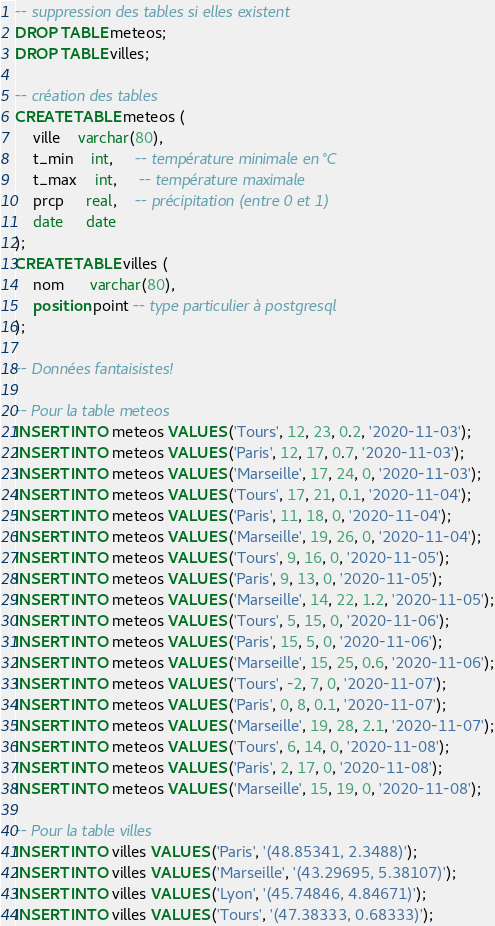<code> <loc_0><loc_0><loc_500><loc_500><_SQL_>-- suppression des tables si elles existent
DROP TABLE meteos;
DROP TABLE villes;

-- création des tables
CREATE TABLE meteos (
    ville    varchar(80),
    t_min    int,     -- température minimale en °C
    t_max    int,     -- température maximale
    prcp     real,    -- précipitation (entre 0 et 1)
    date     date
);
CREATE TABLE villes (
    nom      varchar(80),
    position point -- type particulier à postgresql
);

-- Données fantaisistes!

-- Pour la table meteos
INSERT INTO meteos VALUES ('Tours', 12, 23, 0.2, '2020-11-03');
INSERT INTO meteos VALUES ('Paris', 12, 17, 0.7, '2020-11-03');
INSERT INTO meteos VALUES ('Marseille', 17, 24, 0, '2020-11-03');
INSERT INTO meteos VALUES ('Tours', 17, 21, 0.1, '2020-11-04');
INSERT INTO meteos VALUES ('Paris', 11, 18, 0, '2020-11-04');
INSERT INTO meteos VALUES ('Marseille', 19, 26, 0, '2020-11-04');
INSERT INTO meteos VALUES ('Tours', 9, 16, 0, '2020-11-05');
INSERT INTO meteos VALUES ('Paris', 9, 13, 0, '2020-11-05');
INSERT INTO meteos VALUES ('Marseille', 14, 22, 1.2, '2020-11-05');
INSERT INTO meteos VALUES ('Tours', 5, 15, 0, '2020-11-06');
INSERT INTO meteos VALUES ('Paris', 15, 5, 0, '2020-11-06');
INSERT INTO meteos VALUES ('Marseille', 15, 25, 0.6, '2020-11-06');
INSERT INTO meteos VALUES ('Tours', -2, 7, 0, '2020-11-07');
INSERT INTO meteos VALUES ('Paris', 0, 8, 0.1, '2020-11-07');
INSERT INTO meteos VALUES ('Marseille', 19, 28, 2.1, '2020-11-07');
INSERT INTO meteos VALUES ('Tours', 6, 14, 0, '2020-11-08');
INSERT INTO meteos VALUES ('Paris', 2, 17, 0, '2020-11-08');
INSERT INTO meteos VALUES ('Marseille', 15, 19, 0, '2020-11-08');

-- Pour la table villes
INSERT INTO villes VALUES ('Paris', '(48.85341, 2.3488)');
INSERT INTO villes VALUES ('Marseille', '(43.29695, 5.38107)');
INSERT INTO villes VALUES ('Lyon', '(45.74846, 4.84671)');
INSERT INTO villes VALUES ('Tours', '(47.38333, 0.68333)');</code> 